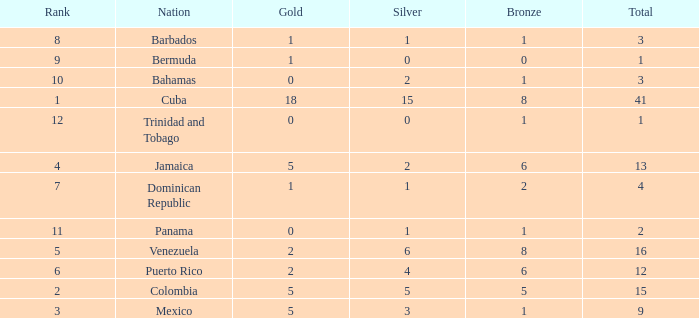Which Bronze is the highest one that has a Rank larger than 1, and a Nation of dominican republic, and a Total larger than 4? None. 